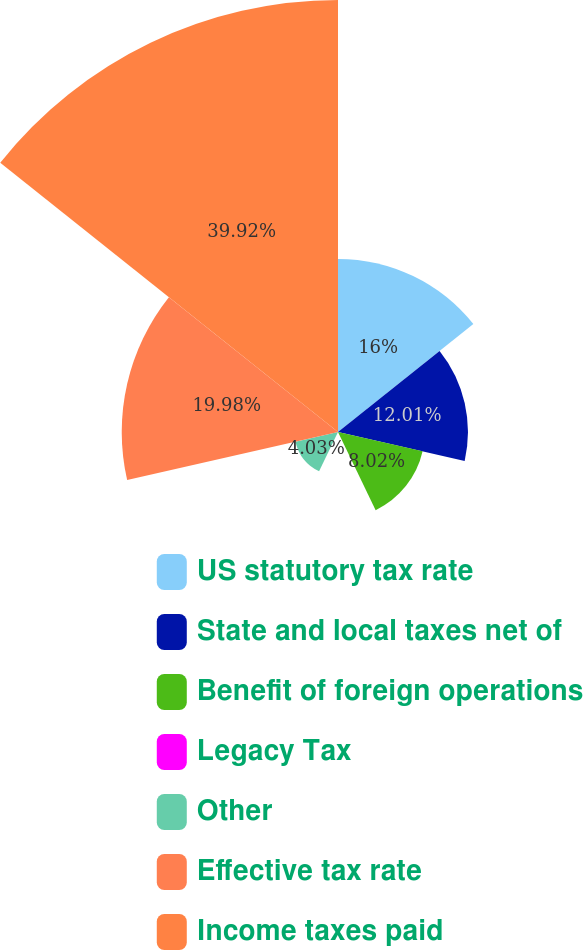Convert chart to OTSL. <chart><loc_0><loc_0><loc_500><loc_500><pie_chart><fcel>US statutory tax rate<fcel>State and local taxes net of<fcel>Benefit of foreign operations<fcel>Legacy Tax<fcel>Other<fcel>Effective tax rate<fcel>Income taxes paid<nl><fcel>16.0%<fcel>12.01%<fcel>8.02%<fcel>0.04%<fcel>4.03%<fcel>19.99%<fcel>39.93%<nl></chart> 